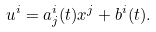Convert formula to latex. <formula><loc_0><loc_0><loc_500><loc_500>u ^ { i } = a ^ { i } _ { j } ( t ) x ^ { j } + b ^ { i } ( t ) .</formula> 